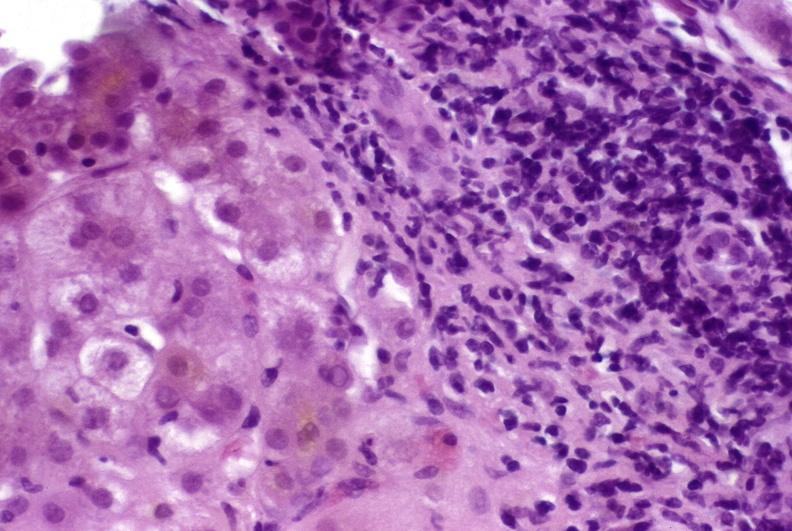does ectopic pancreas show autoimmune hepatitis?
Answer the question using a single word or phrase. No 